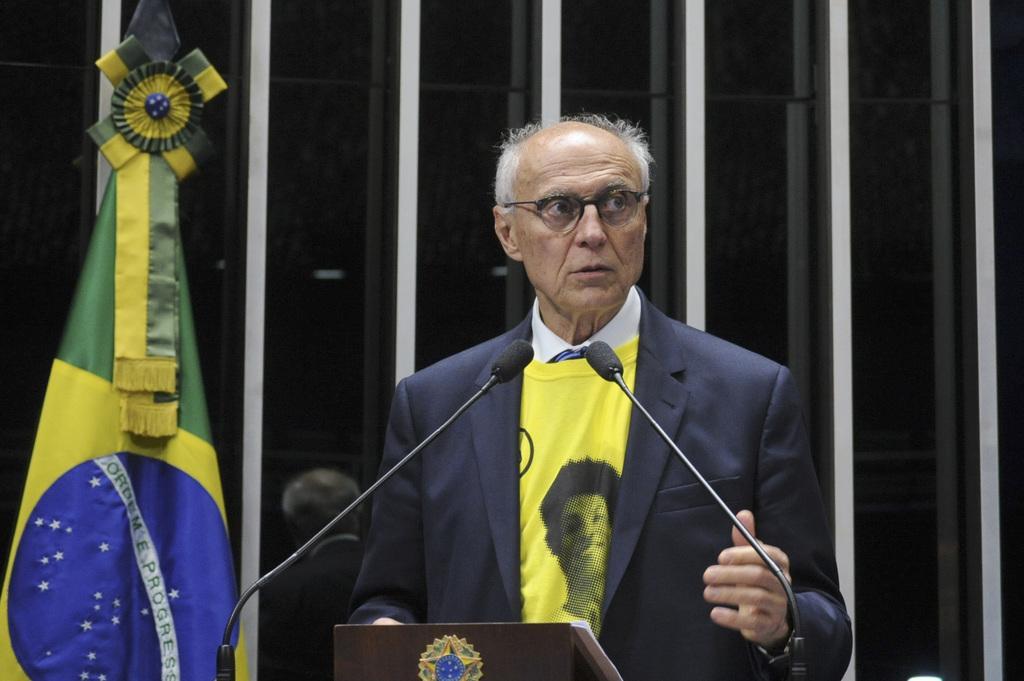How would you summarize this image in a sentence or two? On the left side, there is a flag. On the right side, there is a person in a suit, standing in front of two microphones and a stand, on which there is an object. In the background, there are white color lines. 